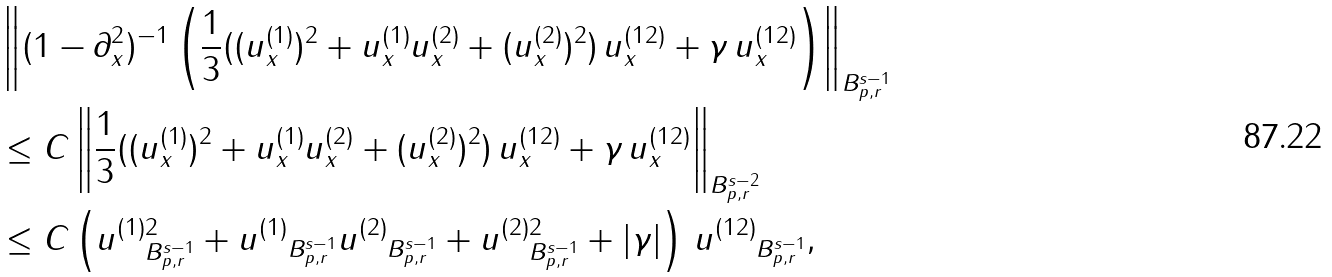<formula> <loc_0><loc_0><loc_500><loc_500>& \left \| ( 1 - \partial _ { x } ^ { 2 } ) ^ { - 1 } \left ( \frac { 1 } { 3 } ( ( u ^ { ( 1 ) } _ { x } ) ^ { 2 } + u ^ { ( 1 ) } _ { x } u ^ { ( 2 ) } _ { x } + ( u ^ { ( 2 ) } _ { x } ) ^ { 2 } ) \, u ^ { ( 1 2 ) } _ { x } + \gamma \, u ^ { ( 1 2 ) } _ { x } \right ) \right \| _ { B ^ { s - 1 } _ { p , r } } \\ & \leq C \left \| \frac { 1 } { 3 } ( ( u ^ { ( 1 ) } _ { x } ) ^ { 2 } + u ^ { ( 1 ) } _ { x } u ^ { ( 2 ) } _ { x } + ( u ^ { ( 2 ) } _ { x } ) ^ { 2 } ) \, u ^ { ( 1 2 ) } _ { x } + \gamma \, u ^ { ( 1 2 ) } _ { x } \right \| _ { B ^ { s - 2 } _ { p , r } } \\ & \leq C \left ( \| u ^ { ( 1 ) } \| _ { B ^ { s - 1 } _ { p , r } } ^ { 2 } + \| u ^ { ( 1 ) } \| _ { B ^ { s - 1 } _ { p , r } } \| u ^ { ( 2 ) } \| _ { B ^ { s - 1 } _ { p , r } } + \| u ^ { ( 2 ) } \| _ { B ^ { s - 1 } _ { p , r } } ^ { 2 } + | \gamma | \right ) \, \| u ^ { ( 1 2 ) } \| _ { B ^ { s - 1 } _ { p , r } } ,</formula> 